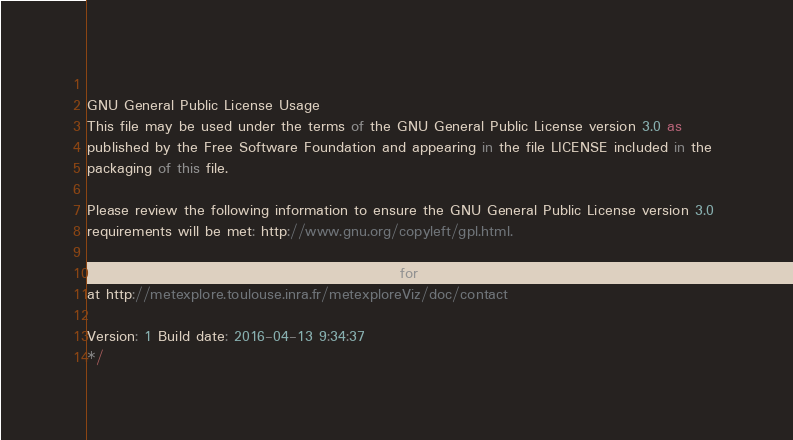Convert code to text. <code><loc_0><loc_0><loc_500><loc_500><_JavaScript_> 
GNU General Public License Usage 
This file may be used under the terms of the GNU General Public License version 3.0 as 
published by the Free Software Foundation and appearing in the file LICENSE included in the 
packaging of this file. 
 
Please review the following information to ensure the GNU General Public License version 3.0 
requirements will be met: http://www.gnu.org/copyleft/gpl.html. 
 
If you are unsure which license is appropriate for your use, please contact us 
at http://metexplore.toulouse.inra.fr/metexploreViz/doc/contact 
 
Version: 1 Build date: 2016-04-13 9:34:37 
*/ </code> 